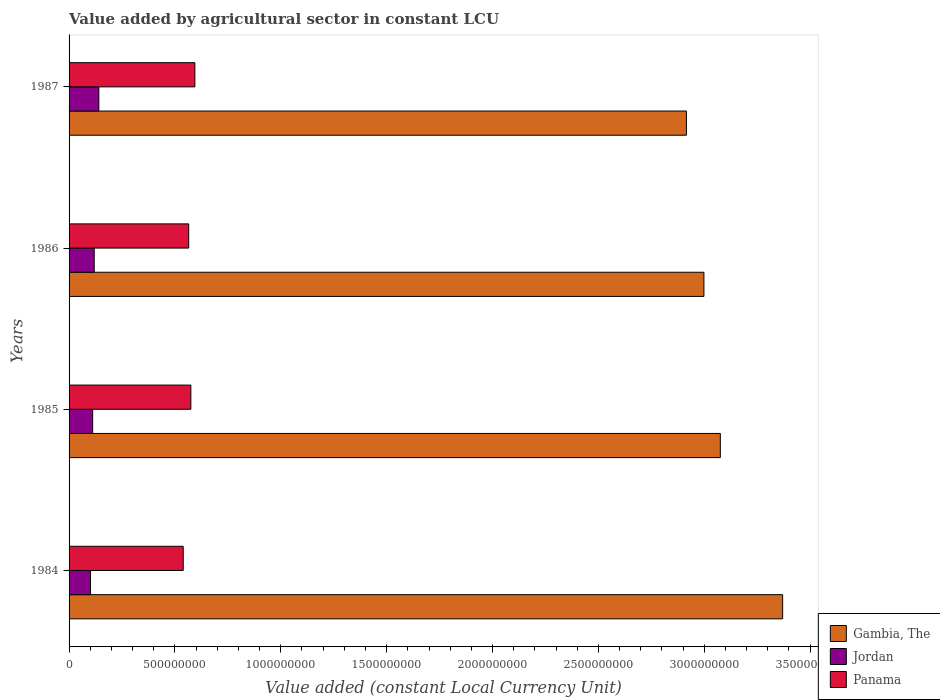How many groups of bars are there?
Keep it short and to the point. 4. Are the number of bars per tick equal to the number of legend labels?
Offer a very short reply. Yes. Are the number of bars on each tick of the Y-axis equal?
Ensure brevity in your answer.  Yes. How many bars are there on the 2nd tick from the top?
Keep it short and to the point. 3. What is the label of the 1st group of bars from the top?
Provide a succinct answer. 1987. In how many cases, is the number of bars for a given year not equal to the number of legend labels?
Provide a succinct answer. 0. What is the value added by agricultural sector in Gambia, The in 1984?
Provide a succinct answer. 3.37e+09. Across all years, what is the maximum value added by agricultural sector in Gambia, The?
Keep it short and to the point. 3.37e+09. Across all years, what is the minimum value added by agricultural sector in Jordan?
Offer a very short reply. 1.01e+08. In which year was the value added by agricultural sector in Panama maximum?
Your answer should be very brief. 1987. In which year was the value added by agricultural sector in Panama minimum?
Keep it short and to the point. 1984. What is the total value added by agricultural sector in Gambia, The in the graph?
Your answer should be compact. 1.24e+1. What is the difference between the value added by agricultural sector in Panama in 1984 and that in 1986?
Provide a short and direct response. -2.59e+07. What is the difference between the value added by agricultural sector in Jordan in 1987 and the value added by agricultural sector in Gambia, The in 1986?
Offer a terse response. -2.86e+09. What is the average value added by agricultural sector in Panama per year?
Your answer should be compact. 5.68e+08. In the year 1984, what is the difference between the value added by agricultural sector in Panama and value added by agricultural sector in Jordan?
Your answer should be compact. 4.38e+08. What is the ratio of the value added by agricultural sector in Jordan in 1984 to that in 1986?
Offer a very short reply. 0.85. What is the difference between the highest and the second highest value added by agricultural sector in Jordan?
Offer a very short reply. 2.20e+07. What is the difference between the highest and the lowest value added by agricultural sector in Jordan?
Give a very brief answer. 3.94e+07. What does the 2nd bar from the top in 1986 represents?
Provide a short and direct response. Jordan. What does the 2nd bar from the bottom in 1985 represents?
Provide a short and direct response. Jordan. How many bars are there?
Offer a very short reply. 12. How many years are there in the graph?
Make the answer very short. 4. Does the graph contain any zero values?
Offer a terse response. No. Does the graph contain grids?
Provide a succinct answer. No. How are the legend labels stacked?
Keep it short and to the point. Vertical. What is the title of the graph?
Provide a short and direct response. Value added by agricultural sector in constant LCU. What is the label or title of the X-axis?
Ensure brevity in your answer.  Value added (constant Local Currency Unit). What is the label or title of the Y-axis?
Your response must be concise. Years. What is the Value added (constant Local Currency Unit) of Gambia, The in 1984?
Keep it short and to the point. 3.37e+09. What is the Value added (constant Local Currency Unit) in Jordan in 1984?
Your response must be concise. 1.01e+08. What is the Value added (constant Local Currency Unit) of Panama in 1984?
Your answer should be compact. 5.39e+08. What is the Value added (constant Local Currency Unit) in Gambia, The in 1985?
Offer a terse response. 3.08e+09. What is the Value added (constant Local Currency Unit) of Jordan in 1985?
Ensure brevity in your answer.  1.11e+08. What is the Value added (constant Local Currency Unit) in Panama in 1985?
Ensure brevity in your answer.  5.75e+08. What is the Value added (constant Local Currency Unit) of Gambia, The in 1986?
Provide a succinct answer. 3.00e+09. What is the Value added (constant Local Currency Unit) of Jordan in 1986?
Your answer should be very brief. 1.19e+08. What is the Value added (constant Local Currency Unit) of Panama in 1986?
Make the answer very short. 5.65e+08. What is the Value added (constant Local Currency Unit) of Gambia, The in 1987?
Offer a terse response. 2.92e+09. What is the Value added (constant Local Currency Unit) in Jordan in 1987?
Offer a very short reply. 1.41e+08. What is the Value added (constant Local Currency Unit) of Panama in 1987?
Make the answer very short. 5.94e+08. Across all years, what is the maximum Value added (constant Local Currency Unit) in Gambia, The?
Your answer should be compact. 3.37e+09. Across all years, what is the maximum Value added (constant Local Currency Unit) of Jordan?
Your response must be concise. 1.41e+08. Across all years, what is the maximum Value added (constant Local Currency Unit) in Panama?
Offer a terse response. 5.94e+08. Across all years, what is the minimum Value added (constant Local Currency Unit) of Gambia, The?
Make the answer very short. 2.92e+09. Across all years, what is the minimum Value added (constant Local Currency Unit) in Jordan?
Your response must be concise. 1.01e+08. Across all years, what is the minimum Value added (constant Local Currency Unit) in Panama?
Ensure brevity in your answer.  5.39e+08. What is the total Value added (constant Local Currency Unit) of Gambia, The in the graph?
Offer a very short reply. 1.24e+1. What is the total Value added (constant Local Currency Unit) in Jordan in the graph?
Give a very brief answer. 4.72e+08. What is the total Value added (constant Local Currency Unit) of Panama in the graph?
Offer a terse response. 2.27e+09. What is the difference between the Value added (constant Local Currency Unit) of Gambia, The in 1984 and that in 1985?
Ensure brevity in your answer.  2.94e+08. What is the difference between the Value added (constant Local Currency Unit) in Jordan in 1984 and that in 1985?
Give a very brief answer. -1.01e+07. What is the difference between the Value added (constant Local Currency Unit) in Panama in 1984 and that in 1985?
Your answer should be compact. -3.60e+07. What is the difference between the Value added (constant Local Currency Unit) of Gambia, The in 1984 and that in 1986?
Ensure brevity in your answer.  3.72e+08. What is the difference between the Value added (constant Local Currency Unit) in Jordan in 1984 and that in 1986?
Offer a terse response. -1.74e+07. What is the difference between the Value added (constant Local Currency Unit) in Panama in 1984 and that in 1986?
Provide a short and direct response. -2.59e+07. What is the difference between the Value added (constant Local Currency Unit) in Gambia, The in 1984 and that in 1987?
Give a very brief answer. 4.54e+08. What is the difference between the Value added (constant Local Currency Unit) in Jordan in 1984 and that in 1987?
Your response must be concise. -3.94e+07. What is the difference between the Value added (constant Local Currency Unit) of Panama in 1984 and that in 1987?
Your answer should be compact. -5.50e+07. What is the difference between the Value added (constant Local Currency Unit) of Gambia, The in 1985 and that in 1986?
Ensure brevity in your answer.  7.75e+07. What is the difference between the Value added (constant Local Currency Unit) in Jordan in 1985 and that in 1986?
Ensure brevity in your answer.  -7.25e+06. What is the difference between the Value added (constant Local Currency Unit) of Panama in 1985 and that in 1986?
Offer a terse response. 1.01e+07. What is the difference between the Value added (constant Local Currency Unit) in Gambia, The in 1985 and that in 1987?
Keep it short and to the point. 1.60e+08. What is the difference between the Value added (constant Local Currency Unit) of Jordan in 1985 and that in 1987?
Give a very brief answer. -2.92e+07. What is the difference between the Value added (constant Local Currency Unit) in Panama in 1985 and that in 1987?
Make the answer very short. -1.90e+07. What is the difference between the Value added (constant Local Currency Unit) of Gambia, The in 1986 and that in 1987?
Provide a succinct answer. 8.27e+07. What is the difference between the Value added (constant Local Currency Unit) in Jordan in 1986 and that in 1987?
Ensure brevity in your answer.  -2.20e+07. What is the difference between the Value added (constant Local Currency Unit) of Panama in 1986 and that in 1987?
Provide a succinct answer. -2.91e+07. What is the difference between the Value added (constant Local Currency Unit) of Gambia, The in 1984 and the Value added (constant Local Currency Unit) of Jordan in 1985?
Provide a short and direct response. 3.26e+09. What is the difference between the Value added (constant Local Currency Unit) of Gambia, The in 1984 and the Value added (constant Local Currency Unit) of Panama in 1985?
Ensure brevity in your answer.  2.79e+09. What is the difference between the Value added (constant Local Currency Unit) in Jordan in 1984 and the Value added (constant Local Currency Unit) in Panama in 1985?
Keep it short and to the point. -4.74e+08. What is the difference between the Value added (constant Local Currency Unit) in Gambia, The in 1984 and the Value added (constant Local Currency Unit) in Jordan in 1986?
Ensure brevity in your answer.  3.25e+09. What is the difference between the Value added (constant Local Currency Unit) of Gambia, The in 1984 and the Value added (constant Local Currency Unit) of Panama in 1986?
Provide a succinct answer. 2.81e+09. What is the difference between the Value added (constant Local Currency Unit) of Jordan in 1984 and the Value added (constant Local Currency Unit) of Panama in 1986?
Your answer should be very brief. -4.64e+08. What is the difference between the Value added (constant Local Currency Unit) of Gambia, The in 1984 and the Value added (constant Local Currency Unit) of Jordan in 1987?
Ensure brevity in your answer.  3.23e+09. What is the difference between the Value added (constant Local Currency Unit) in Gambia, The in 1984 and the Value added (constant Local Currency Unit) in Panama in 1987?
Provide a short and direct response. 2.78e+09. What is the difference between the Value added (constant Local Currency Unit) in Jordan in 1984 and the Value added (constant Local Currency Unit) in Panama in 1987?
Your response must be concise. -4.93e+08. What is the difference between the Value added (constant Local Currency Unit) of Gambia, The in 1985 and the Value added (constant Local Currency Unit) of Jordan in 1986?
Give a very brief answer. 2.96e+09. What is the difference between the Value added (constant Local Currency Unit) of Gambia, The in 1985 and the Value added (constant Local Currency Unit) of Panama in 1986?
Provide a short and direct response. 2.51e+09. What is the difference between the Value added (constant Local Currency Unit) of Jordan in 1985 and the Value added (constant Local Currency Unit) of Panama in 1986?
Provide a succinct answer. -4.54e+08. What is the difference between the Value added (constant Local Currency Unit) of Gambia, The in 1985 and the Value added (constant Local Currency Unit) of Jordan in 1987?
Your answer should be very brief. 2.94e+09. What is the difference between the Value added (constant Local Currency Unit) in Gambia, The in 1985 and the Value added (constant Local Currency Unit) in Panama in 1987?
Offer a terse response. 2.48e+09. What is the difference between the Value added (constant Local Currency Unit) of Jordan in 1985 and the Value added (constant Local Currency Unit) of Panama in 1987?
Keep it short and to the point. -4.83e+08. What is the difference between the Value added (constant Local Currency Unit) of Gambia, The in 1986 and the Value added (constant Local Currency Unit) of Jordan in 1987?
Your response must be concise. 2.86e+09. What is the difference between the Value added (constant Local Currency Unit) in Gambia, The in 1986 and the Value added (constant Local Currency Unit) in Panama in 1987?
Offer a very short reply. 2.40e+09. What is the difference between the Value added (constant Local Currency Unit) of Jordan in 1986 and the Value added (constant Local Currency Unit) of Panama in 1987?
Your answer should be very brief. -4.75e+08. What is the average Value added (constant Local Currency Unit) of Gambia, The per year?
Offer a terse response. 3.09e+09. What is the average Value added (constant Local Currency Unit) of Jordan per year?
Keep it short and to the point. 1.18e+08. What is the average Value added (constant Local Currency Unit) of Panama per year?
Provide a succinct answer. 5.68e+08. In the year 1984, what is the difference between the Value added (constant Local Currency Unit) of Gambia, The and Value added (constant Local Currency Unit) of Jordan?
Provide a succinct answer. 3.27e+09. In the year 1984, what is the difference between the Value added (constant Local Currency Unit) in Gambia, The and Value added (constant Local Currency Unit) in Panama?
Make the answer very short. 2.83e+09. In the year 1984, what is the difference between the Value added (constant Local Currency Unit) of Jordan and Value added (constant Local Currency Unit) of Panama?
Your response must be concise. -4.38e+08. In the year 1985, what is the difference between the Value added (constant Local Currency Unit) in Gambia, The and Value added (constant Local Currency Unit) in Jordan?
Your response must be concise. 2.96e+09. In the year 1985, what is the difference between the Value added (constant Local Currency Unit) in Gambia, The and Value added (constant Local Currency Unit) in Panama?
Your answer should be very brief. 2.50e+09. In the year 1985, what is the difference between the Value added (constant Local Currency Unit) of Jordan and Value added (constant Local Currency Unit) of Panama?
Make the answer very short. -4.64e+08. In the year 1986, what is the difference between the Value added (constant Local Currency Unit) in Gambia, The and Value added (constant Local Currency Unit) in Jordan?
Your response must be concise. 2.88e+09. In the year 1986, what is the difference between the Value added (constant Local Currency Unit) in Gambia, The and Value added (constant Local Currency Unit) in Panama?
Offer a very short reply. 2.43e+09. In the year 1986, what is the difference between the Value added (constant Local Currency Unit) of Jordan and Value added (constant Local Currency Unit) of Panama?
Provide a short and direct response. -4.46e+08. In the year 1987, what is the difference between the Value added (constant Local Currency Unit) of Gambia, The and Value added (constant Local Currency Unit) of Jordan?
Give a very brief answer. 2.77e+09. In the year 1987, what is the difference between the Value added (constant Local Currency Unit) in Gambia, The and Value added (constant Local Currency Unit) in Panama?
Your answer should be compact. 2.32e+09. In the year 1987, what is the difference between the Value added (constant Local Currency Unit) of Jordan and Value added (constant Local Currency Unit) of Panama?
Your answer should be compact. -4.53e+08. What is the ratio of the Value added (constant Local Currency Unit) in Gambia, The in 1984 to that in 1985?
Offer a terse response. 1.1. What is the ratio of the Value added (constant Local Currency Unit) in Jordan in 1984 to that in 1985?
Offer a very short reply. 0.91. What is the ratio of the Value added (constant Local Currency Unit) in Panama in 1984 to that in 1985?
Your answer should be very brief. 0.94. What is the ratio of the Value added (constant Local Currency Unit) in Gambia, The in 1984 to that in 1986?
Provide a short and direct response. 1.12. What is the ratio of the Value added (constant Local Currency Unit) of Jordan in 1984 to that in 1986?
Provide a short and direct response. 0.85. What is the ratio of the Value added (constant Local Currency Unit) in Panama in 1984 to that in 1986?
Your response must be concise. 0.95. What is the ratio of the Value added (constant Local Currency Unit) of Gambia, The in 1984 to that in 1987?
Your response must be concise. 1.16. What is the ratio of the Value added (constant Local Currency Unit) in Jordan in 1984 to that in 1987?
Your answer should be compact. 0.72. What is the ratio of the Value added (constant Local Currency Unit) of Panama in 1984 to that in 1987?
Offer a terse response. 0.91. What is the ratio of the Value added (constant Local Currency Unit) in Gambia, The in 1985 to that in 1986?
Ensure brevity in your answer.  1.03. What is the ratio of the Value added (constant Local Currency Unit) of Jordan in 1985 to that in 1986?
Your answer should be very brief. 0.94. What is the ratio of the Value added (constant Local Currency Unit) of Panama in 1985 to that in 1986?
Offer a very short reply. 1.02. What is the ratio of the Value added (constant Local Currency Unit) in Gambia, The in 1985 to that in 1987?
Make the answer very short. 1.05. What is the ratio of the Value added (constant Local Currency Unit) in Jordan in 1985 to that in 1987?
Make the answer very short. 0.79. What is the ratio of the Value added (constant Local Currency Unit) in Panama in 1985 to that in 1987?
Give a very brief answer. 0.97. What is the ratio of the Value added (constant Local Currency Unit) of Gambia, The in 1986 to that in 1987?
Your answer should be very brief. 1.03. What is the ratio of the Value added (constant Local Currency Unit) in Jordan in 1986 to that in 1987?
Offer a very short reply. 0.84. What is the ratio of the Value added (constant Local Currency Unit) in Panama in 1986 to that in 1987?
Provide a succinct answer. 0.95. What is the difference between the highest and the second highest Value added (constant Local Currency Unit) in Gambia, The?
Your response must be concise. 2.94e+08. What is the difference between the highest and the second highest Value added (constant Local Currency Unit) in Jordan?
Make the answer very short. 2.20e+07. What is the difference between the highest and the second highest Value added (constant Local Currency Unit) in Panama?
Provide a short and direct response. 1.90e+07. What is the difference between the highest and the lowest Value added (constant Local Currency Unit) of Gambia, The?
Offer a very short reply. 4.54e+08. What is the difference between the highest and the lowest Value added (constant Local Currency Unit) in Jordan?
Your answer should be compact. 3.94e+07. What is the difference between the highest and the lowest Value added (constant Local Currency Unit) in Panama?
Provide a succinct answer. 5.50e+07. 